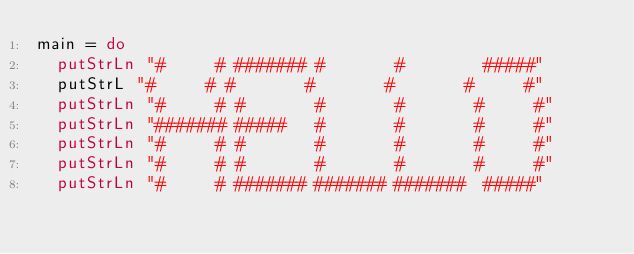<code> <loc_0><loc_0><loc_500><loc_500><_Haskell_>main = do
  putStrLn "#     # ####### #       #        #####"
  putStrL "#     # #       #       #       #     #"
  putStrLn "#     # #       #       #       #     #"
  putStrLn "####### #####   #       #       #     #"
  putStrLn "#     # #       #       #       #     #"
  putStrLn "#     # #       #       #       #     #"
  putStrLn "#     # ####### ####### #######  #####"
</code> 